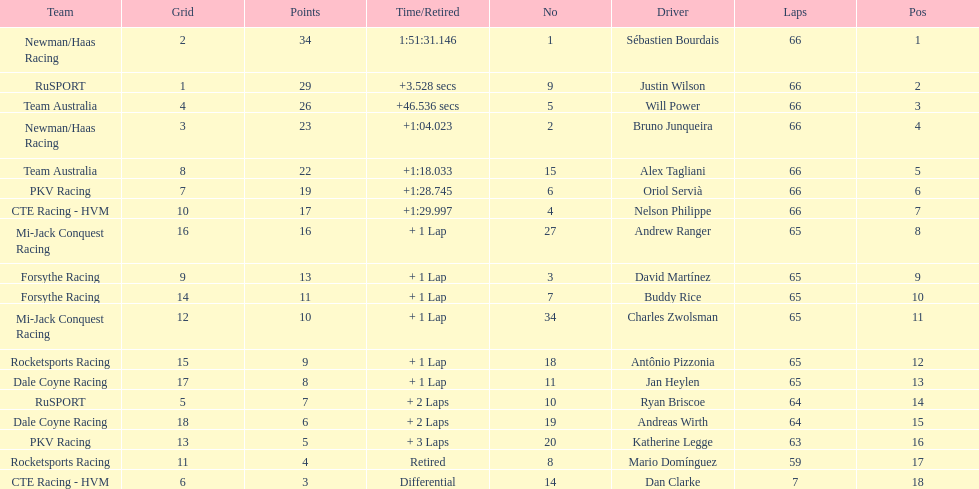Who are the drivers? Sébastien Bourdais, Justin Wilson, Will Power, Bruno Junqueira, Alex Tagliani, Oriol Servià, Nelson Philippe, Andrew Ranger, David Martínez, Buddy Rice, Charles Zwolsman, Antônio Pizzonia, Jan Heylen, Ryan Briscoe, Andreas Wirth, Katherine Legge, Mario Domínguez, Dan Clarke. What are their numbers? 1, 9, 5, 2, 15, 6, 4, 27, 3, 7, 34, 18, 11, 10, 19, 20, 8, 14. What are their positions? 1, 2, 3, 4, 5, 6, 7, 8, 9, 10, 11, 12, 13, 14, 15, 16, 17, 18. Which driver has the same number and position? Sébastien Bourdais. 